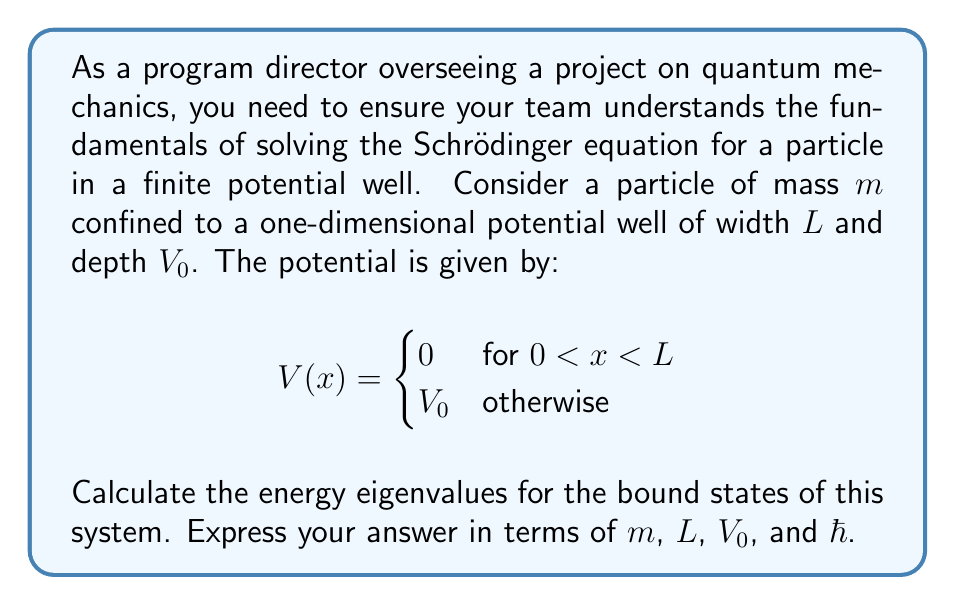Can you solve this math problem? To solve this problem, we'll follow these steps:

1) The time-independent Schrödinger equation is:

   $$-\frac{\hbar^2}{2m}\frac{d^2\psi}{dx^2} + V(x)\psi = E\psi$$

2) Inside the well (0 < x < L), V(x) = 0, so the equation becomes:

   $$-\frac{\hbar^2}{2m}\frac{d^2\psi}{dx^2} = E\psi$$

3) The general solution inside the well is:

   $$\psi(x) = A\sin(kx) + B\cos(kx)$$

   where $k = \sqrt{\frac{2mE}{\hbar^2}}$

4) Outside the well, the wavefunction decays exponentially:

   $$\psi(x) = Ce^{-\alpha x} \text{ for } x < 0$$
   $$\psi(x) = De^{-\alpha(x-L)} \text{ for } x > L$$

   where $\alpha = \sqrt{\frac{2m(V_0-E)}{\hbar^2}}$

5) Applying continuity of $\psi$ and $\frac{d\psi}{dx}$ at x = 0 and x = L, we get:

   $$\tan(kL) = \frac{2k\alpha}{k^2-\alpha^2}$$

6) This transcendental equation determines the allowed values of k, and thus E.

7) For even states: $\tan(\frac{kL}{2}) = \frac{\alpha}{k}$
   For odd states: $\cot(\frac{kL}{2}) = -\frac{\alpha}{k}$

8) These equations can be solved numerically to find the energy eigenvalues.

9) The energy eigenvalues are given by:

   $$E_n = \frac{\hbar^2k_n^2}{2m}$$

   where $k_n$ are the solutions to the transcendental equations.
Answer: $E_n = \frac{\hbar^2k_n^2}{2m}$, where $k_n$ satisfies $\tan(kL) = \frac{2k\alpha}{k^2-\alpha^2}$ with $\alpha = \sqrt{\frac{2m(V_0-E)}{\hbar^2}}$ 